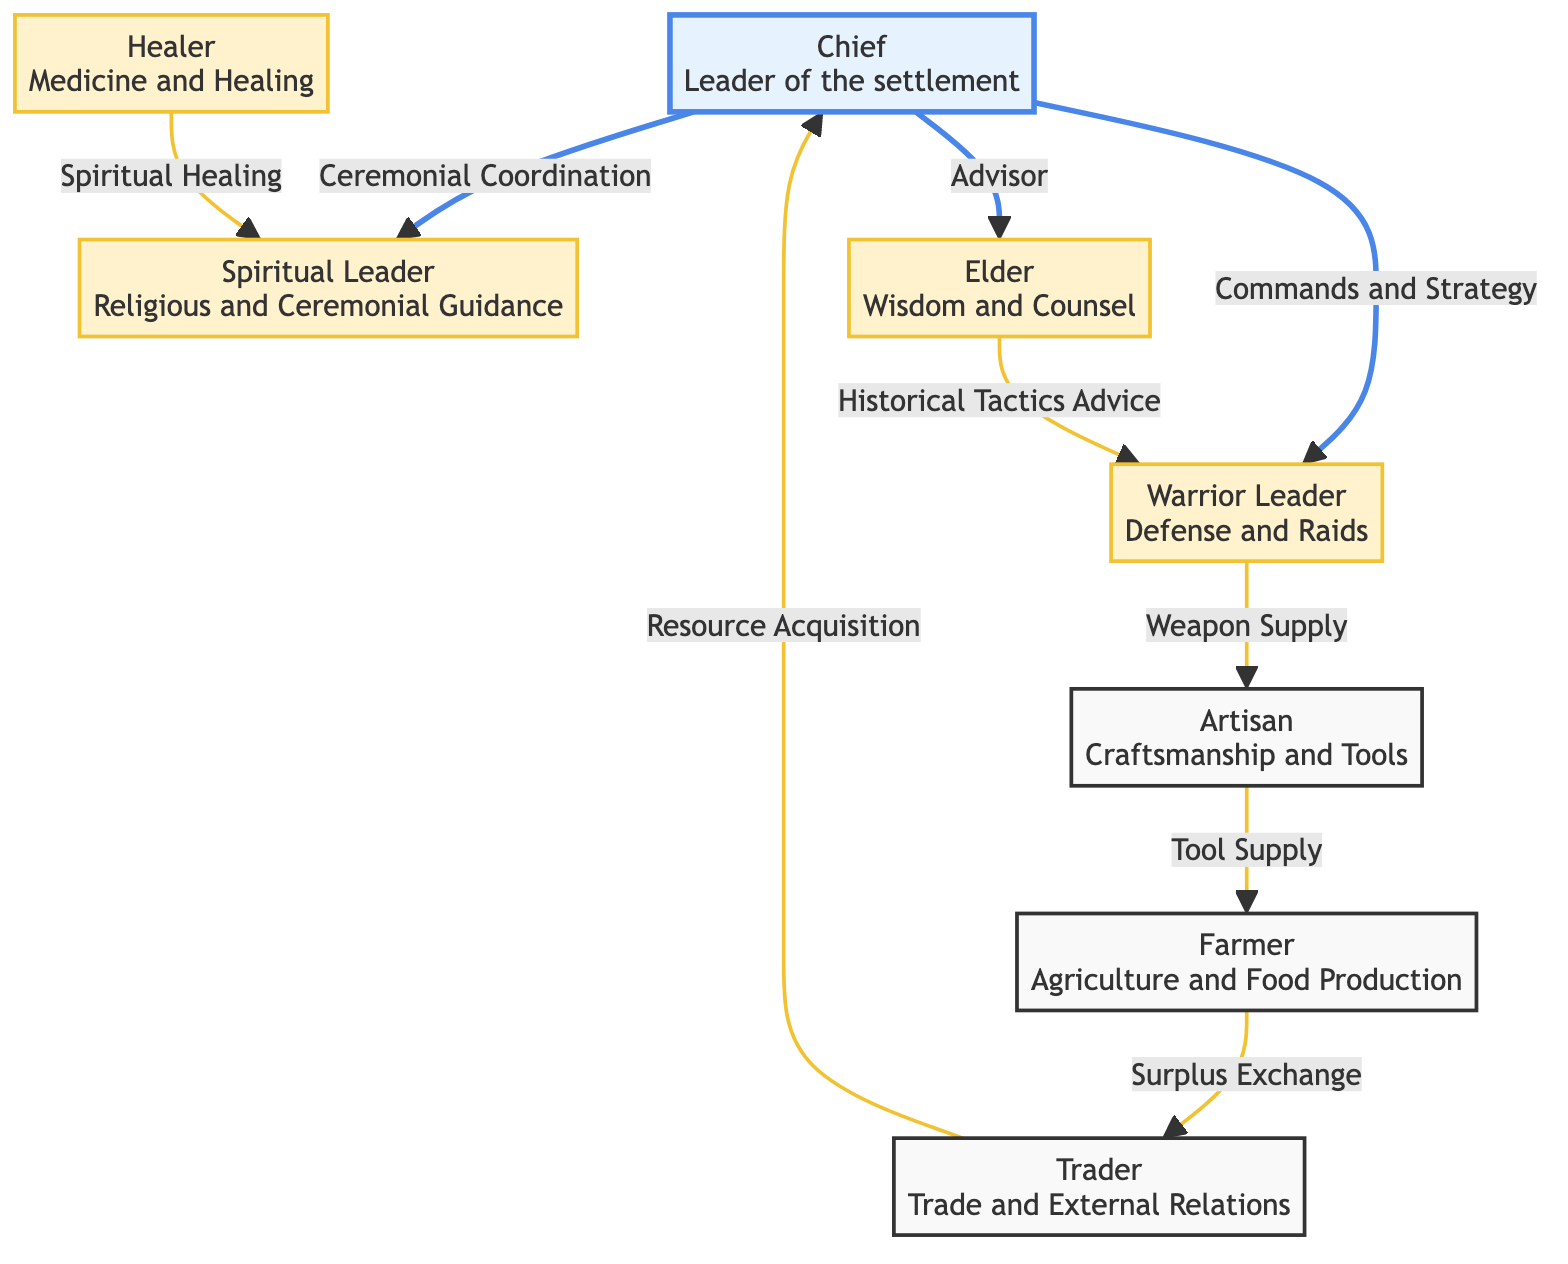What is the role of the Chief? The Chief is identified in the diagram as the leader of the settlement, and therefore their primary role is to oversee and guide the community as a whole.
Answer: Leader of the settlement How many nodes are in the diagram? The diagram contains eight distinct nodes, each representing a different role within the Iron Age settlement.
Answer: 8 Who supplies tools to the Farmer? According to the edges in the diagram, the Artisan supplies tools to the Farmer, indicating a direct relationship where the Artisan's role is to provide craftsmanship support.
Answer: Artisan What relationship does the Elder have with the Warrior Leader? The diagram shows that the Elder provides advice to the Warrior Leader regarding historical tactics, establishing a channel of communication and information flow between these two roles.
Answer: Historical Tactics Advice How does the Farmer connect to the Trader? The connection between the Farmer and the Trader is established through a surplus exchange relationship, illustrating the economic interaction between food production and trade.
Answer: Surplus Exchange Who interacts with both the Spiritual Leader and the Healer? The Healer interacts with the Spiritual Leader as they are involved in spiritual healing, thus creating a relationship between them, while the Chief also maintains a connection with the Spiritual Leader through ceremonial coordination.
Answer: Healer Which role provides spiritual and ceremonial guidance? The diagram indicates that the Spiritual Leader is responsible for providing spiritual and ceremonial guidance, making this role pivotal in the cultural practices of the settlement.
Answer: Spiritual Leader What type of network is represented in this diagram? The diagram clearly depicts a social and clan network within the Iron Age settlement, showcasing the interactions and relationships among various roles present in the community.
Answer: Social and Clan Network What is the relationship between the Trader and the Chief? The Trader has a direct relationship with the Chief based on resource acquisition, indicating that the Trader plays a significant role in supplying essential resources to the leadership of the settlement.
Answer: Resource Acquisition 